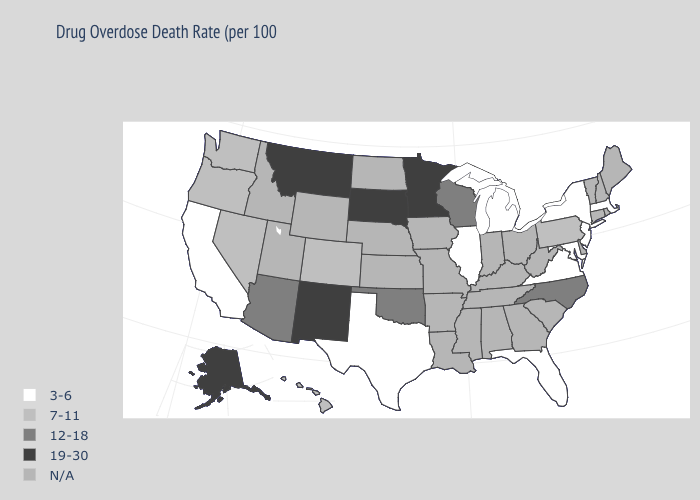What is the value of Delaware?
Quick response, please. N/A. Does the first symbol in the legend represent the smallest category?
Answer briefly. Yes. What is the value of Mississippi?
Short answer required. N/A. How many symbols are there in the legend?
Write a very short answer. 5. Among the states that border Connecticut , which have the lowest value?
Write a very short answer. Massachusetts, New York. Name the states that have a value in the range N/A?
Be succinct. Alabama, Arkansas, Connecticut, Delaware, Georgia, Idaho, Indiana, Iowa, Kansas, Kentucky, Louisiana, Maine, Mississippi, Missouri, Nebraska, New Hampshire, North Dakota, Ohio, Rhode Island, South Carolina, Tennessee, Utah, Vermont, West Virginia, Wyoming. What is the highest value in the USA?
Concise answer only. 19-30. Name the states that have a value in the range 3-6?
Be succinct. California, Florida, Illinois, Maryland, Massachusetts, Michigan, New Jersey, New York, Texas, Virginia. Name the states that have a value in the range 3-6?
Be succinct. California, Florida, Illinois, Maryland, Massachusetts, Michigan, New Jersey, New York, Texas, Virginia. Which states hav the highest value in the South?
Answer briefly. North Carolina, Oklahoma. How many symbols are there in the legend?
Keep it brief. 5. What is the value of Rhode Island?
Write a very short answer. N/A. 